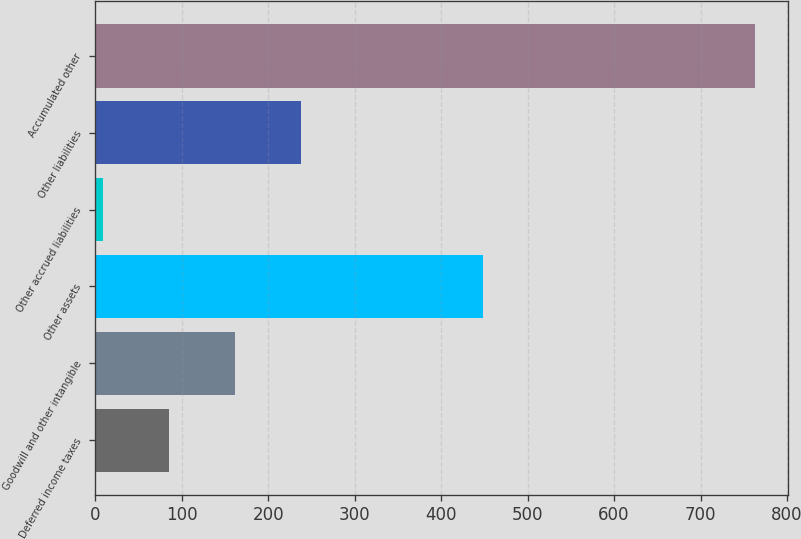Convert chart. <chart><loc_0><loc_0><loc_500><loc_500><bar_chart><fcel>Deferred income taxes<fcel>Goodwill and other intangible<fcel>Other assets<fcel>Other accrued liabilities<fcel>Other liabilities<fcel>Accumulated other<nl><fcel>85.4<fcel>161.8<fcel>448<fcel>9<fcel>238.2<fcel>763<nl></chart> 